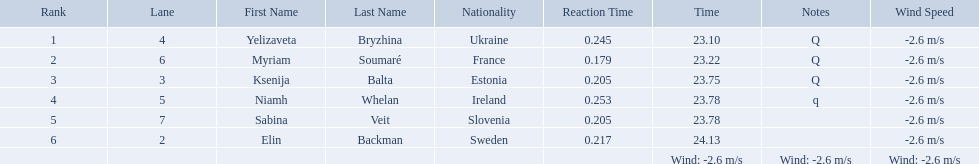Which athlete is from sweden? Elin Backman. What was their time to finish the race? 24.13. 